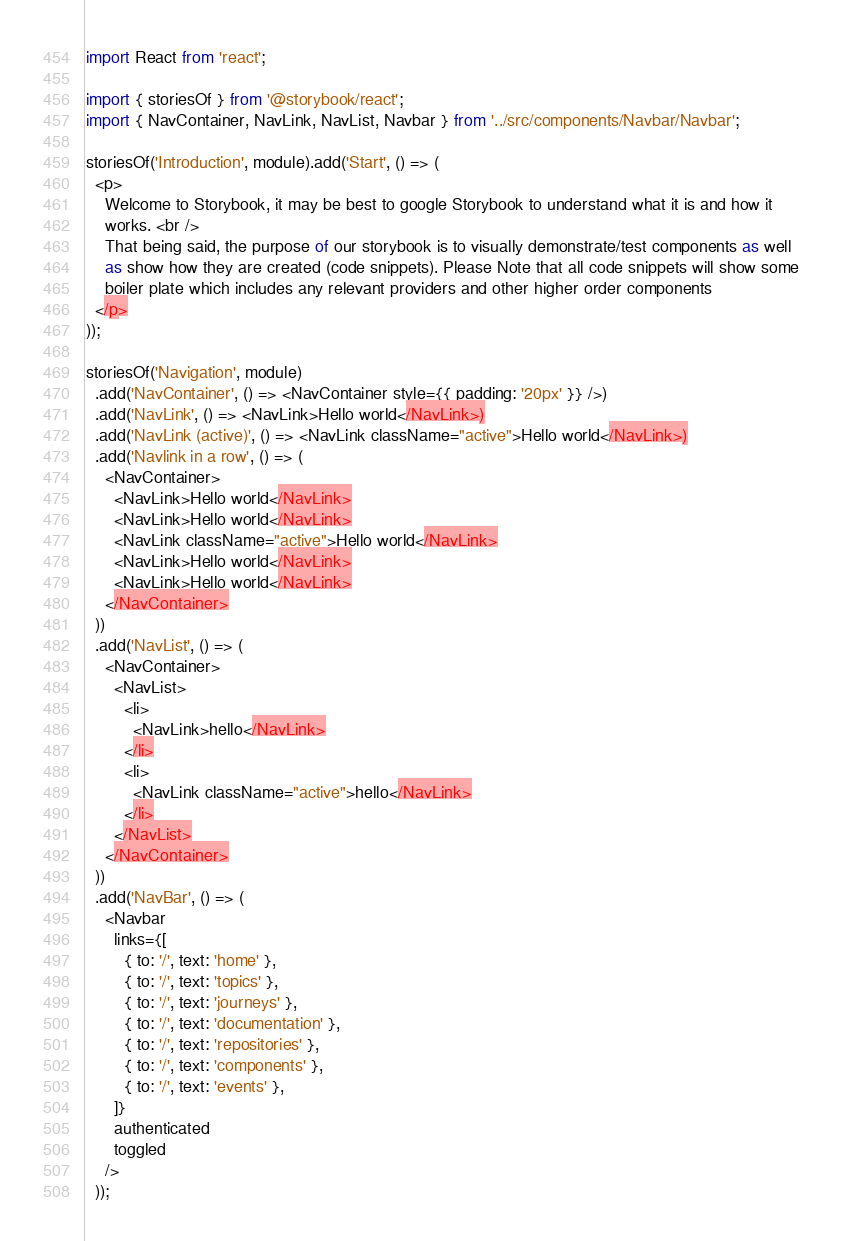<code> <loc_0><loc_0><loc_500><loc_500><_JavaScript_>import React from 'react';

import { storiesOf } from '@storybook/react';
import { NavContainer, NavLink, NavList, Navbar } from '../src/components/Navbar/Navbar';

storiesOf('Introduction', module).add('Start', () => (
  <p>
    Welcome to Storybook, it may be best to google Storybook to understand what it is and how it
    works. <br />
    That being said, the purpose of our storybook is to visually demonstrate/test components as well
    as show how they are created (code snippets). Please Note that all code snippets will show some
    boiler plate which includes any relevant providers and other higher order components
  </p>
));

storiesOf('Navigation', module)
  .add('NavContainer', () => <NavContainer style={{ padding: '20px' }} />)
  .add('NavLink', () => <NavLink>Hello world</NavLink>)
  .add('NavLink (active)', () => <NavLink className="active">Hello world</NavLink>)
  .add('Navlink in a row', () => (
    <NavContainer>
      <NavLink>Hello world</NavLink>
      <NavLink>Hello world</NavLink>
      <NavLink className="active">Hello world</NavLink>
      <NavLink>Hello world</NavLink>
      <NavLink>Hello world</NavLink>
    </NavContainer>
  ))
  .add('NavList', () => (
    <NavContainer>
      <NavList>
        <li>
          <NavLink>hello</NavLink>
        </li>
        <li>
          <NavLink className="active">hello</NavLink>
        </li>
      </NavList>
    </NavContainer>
  ))
  .add('NavBar', () => (
    <Navbar
      links={[
        { to: '/', text: 'home' },
        { to: '/', text: 'topics' },
        { to: '/', text: 'journeys' },
        { to: '/', text: 'documentation' },
        { to: '/', text: 'repositories' },
        { to: '/', text: 'components' },
        { to: '/', text: 'events' },
      ]}
      authenticated
      toggled
    />
  ));
</code> 